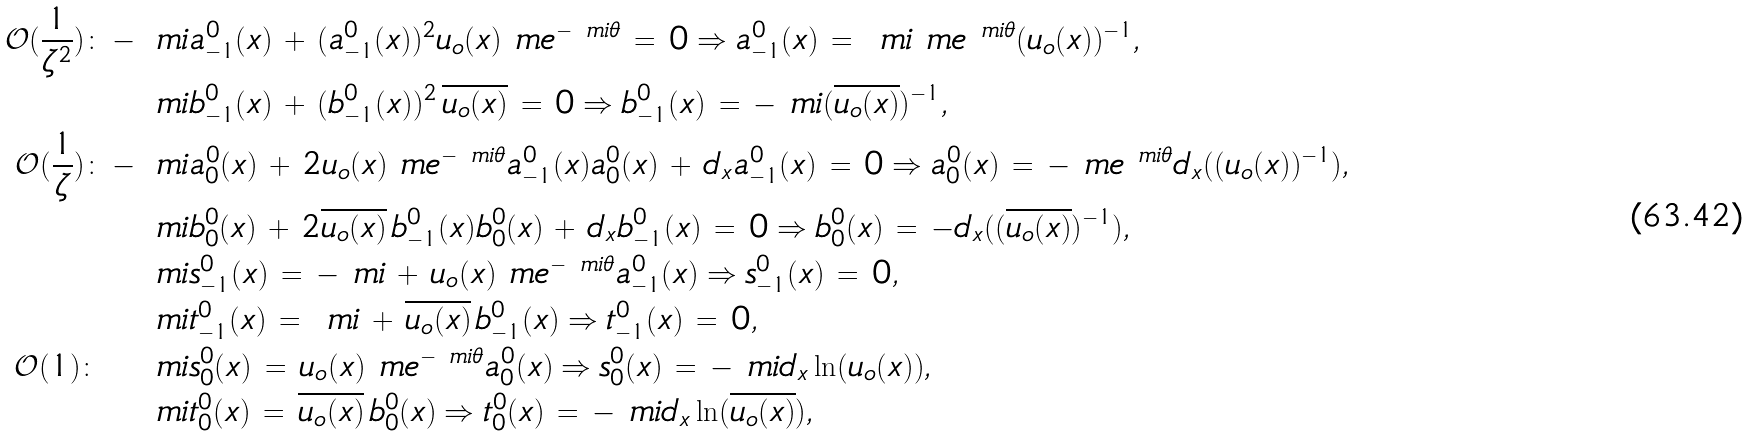Convert formula to latex. <formula><loc_0><loc_0><loc_500><loc_500>\mathcal { O } ( \frac { 1 } { \zeta ^ { 2 } } ) \colon - \ m i & a _ { - 1 } ^ { 0 } ( x ) \, + \, ( a _ { - 1 } ^ { 0 } ( x ) ) ^ { 2 } u _ { o } ( x ) \ m e ^ { - \ m i \theta } \, = \, 0 \Rightarrow a _ { - 1 } ^ { 0 } ( x ) \, = \, \ m i \ m e ^ { \ m i \theta } ( u _ { o } ( x ) ) ^ { - 1 } , \\ \ m i & b _ { - 1 } ^ { 0 } ( x ) \, + \, ( b _ { - 1 } ^ { 0 } ( x ) ) ^ { 2 } \, \overline { u _ { o } ( x ) } \, = \, 0 \Rightarrow b _ { - 1 } ^ { 0 } ( x ) \, = \, - \ m i ( \overline { u _ { o } ( x ) } ) ^ { - 1 } , \\ \mathcal { O } ( \frac { 1 } { \zeta } ) \colon - \ m i & a _ { 0 } ^ { 0 } ( x ) \, + \, 2 u _ { o } ( x ) \ m e ^ { - \ m i \theta } a _ { - 1 } ^ { 0 } ( x ) a _ { 0 } ^ { 0 } ( x ) \, + \, d _ { x } a _ { - 1 } ^ { 0 } ( x ) \, = \, 0 \Rightarrow a _ { 0 } ^ { 0 } ( x ) \, = \, - \ m e ^ { \ m i \theta } d _ { x } ( ( u _ { o } ( x ) ) ^ { - 1 } ) , \\ \ m i & b _ { 0 } ^ { 0 } ( x ) \, + \, 2 \overline { u _ { o } ( x ) } \, b _ { - 1 } ^ { 0 } ( x ) b _ { 0 } ^ { 0 } ( x ) \, + \, d _ { x } b _ { - 1 } ^ { 0 } ( x ) \, = \, 0 \Rightarrow b _ { 0 } ^ { 0 } ( x ) \, = \, - d _ { x } ( ( \overline { u _ { o } ( x ) } ) ^ { - 1 } ) , \\ \ m i & s _ { - 1 } ^ { 0 } ( x ) \, = \, - \ m i \, + \, u _ { o } ( x ) \ m e ^ { - \ m i \theta } a _ { - 1 } ^ { 0 } ( x ) \Rightarrow s _ { - 1 } ^ { 0 } ( x ) \, = \, 0 , \\ \ m i & t _ { - 1 } ^ { 0 } ( x ) \, = \, \ m i \, + \, \overline { u _ { o } ( x ) } \, b _ { - 1 } ^ { 0 } ( x ) \Rightarrow t _ { - 1 } ^ { 0 } ( x ) \, = \, 0 , \\ \mathcal { O } ( 1 ) \colon \, \quad \ m i & s _ { 0 } ^ { 0 } ( x ) \, = \, u _ { o } ( x ) \ m e ^ { - \ m i \theta } a _ { 0 } ^ { 0 } ( x ) \Rightarrow s _ { 0 } ^ { 0 } ( x ) \, = \, - \ m i d _ { x } \ln ( u _ { o } ( x ) ) , \\ \ m i & t _ { 0 } ^ { 0 } ( x ) \, = \, \overline { u _ { o } ( x ) } \, b _ { 0 } ^ { 0 } ( x ) \Rightarrow t _ { 0 } ^ { 0 } ( x ) \, = \, - \ m i d _ { x } \ln ( \overline { u _ { o } ( x ) } ) ,</formula> 